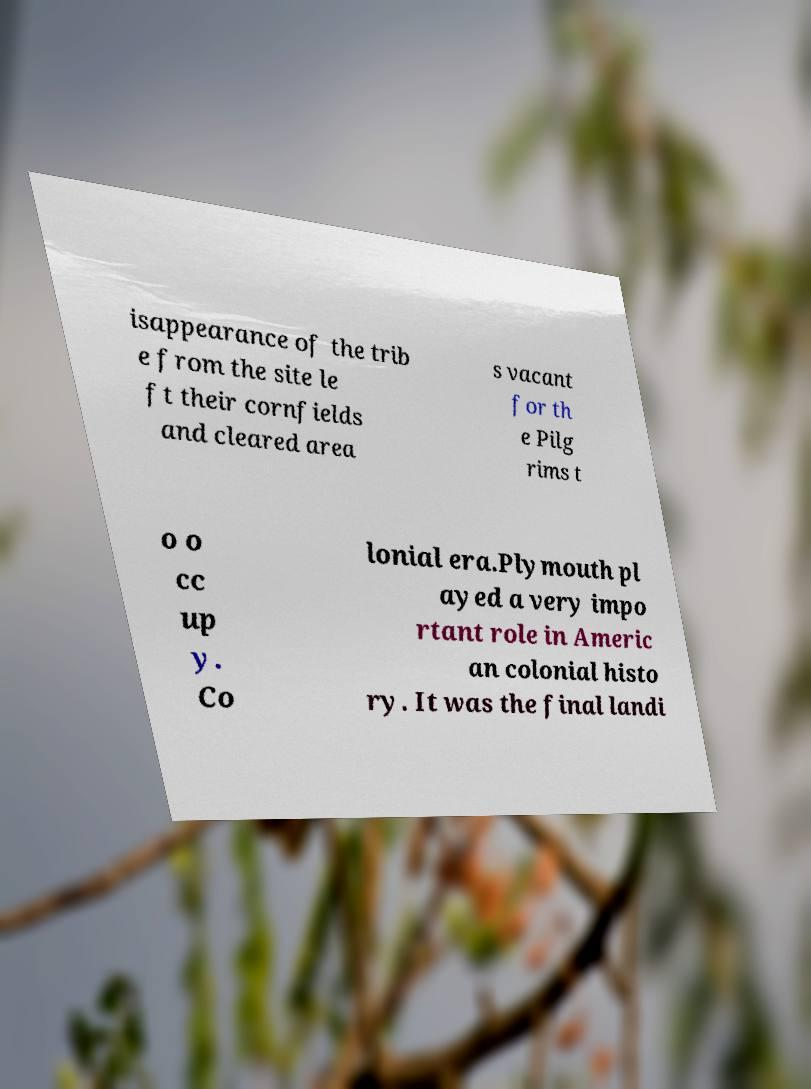Can you read and provide the text displayed in the image?This photo seems to have some interesting text. Can you extract and type it out for me? isappearance of the trib e from the site le ft their cornfields and cleared area s vacant for th e Pilg rims t o o cc up y. Co lonial era.Plymouth pl ayed a very impo rtant role in Americ an colonial histo ry. It was the final landi 